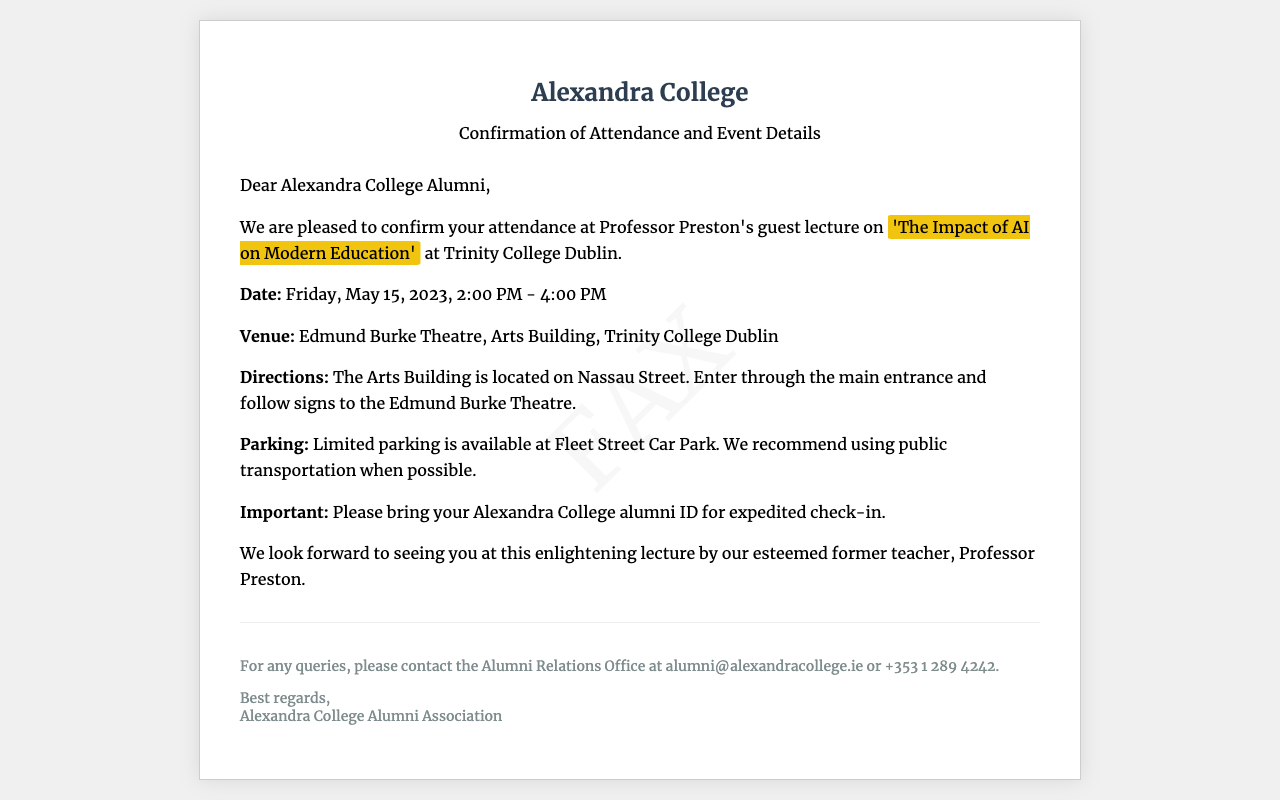What is the title of the guest lecture? The title of the guest lecture is specified in the document as 'The Impact of AI on Modern Education.'
Answer: 'The Impact of AI on Modern Education' What is the date of the guest lecture? The date is clearly stated in the document as May 15, 2023.
Answer: May 15, 2023 Where is the guest lecture taking place? The venue is explicitly mentioned in the document as the Edmund Burke Theatre, Arts Building, Trinity College Dublin.
Answer: Edmund Burke Theatre, Arts Building, Trinity College Dublin Is parking readily available at the venue? The document indicates that parking is limited and recommends using public transportation when possible.
Answer: Limited parking available What time does the guest lecture start? The starting time of the lecture is included in the document as 2:00 PM.
Answer: 2:00 PM What is required for expedited check-in? The document emphasizes the need to bring an Alexandra College alumni ID for expedited check-in.
Answer: Alexandra College alumni ID What is the contact email for queries? The document provides a contact email for queries, which is alumni@alexandracollege.ie.
Answer: alumni@alexandracollege.ie What is the purpose of this document? The document serves to confirm attendance at the guest lecture and provide event details.
Answer: Confirm attendance What is the name of the professor giving the lecture? The professor's name is mentioned in the document as Professor Preston.
Answer: Professor Preston 